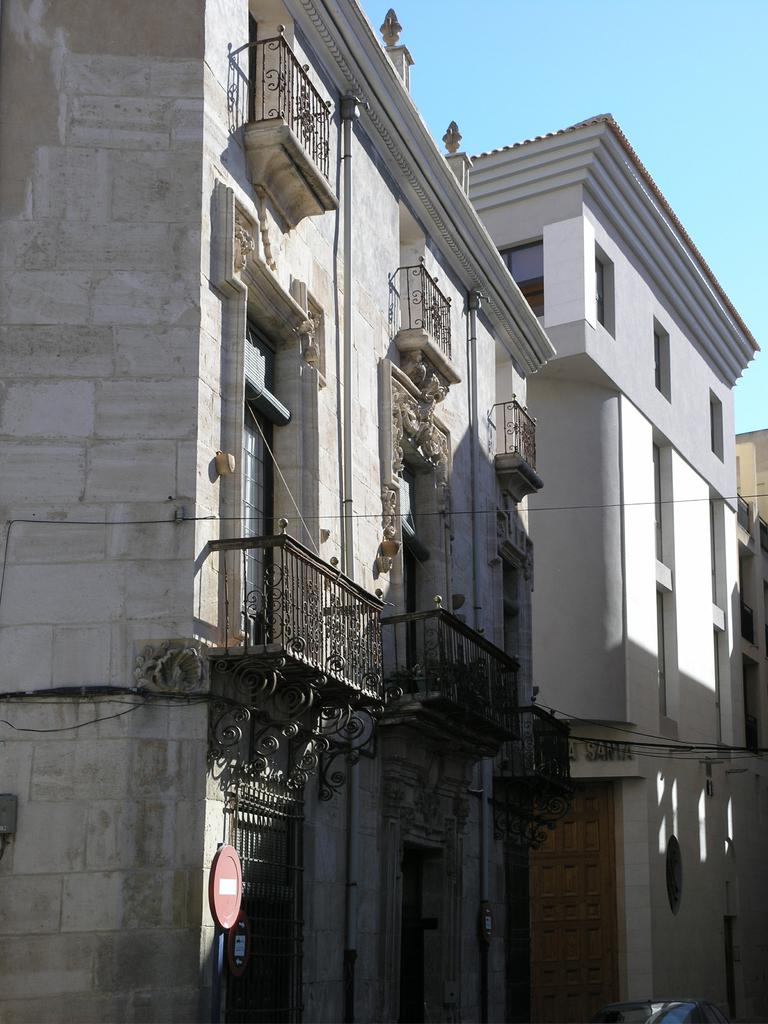What type of structures are visible in the image? There are buildings in the image. What feature do the buildings have? The buildings have windows. What can be seen on the windows in the image? The windows are covered with grills. What is the name of the person who is about to embark on a voyage in the image? There is no person or voyage present in the image; it only features buildings with windows covered by grills. 